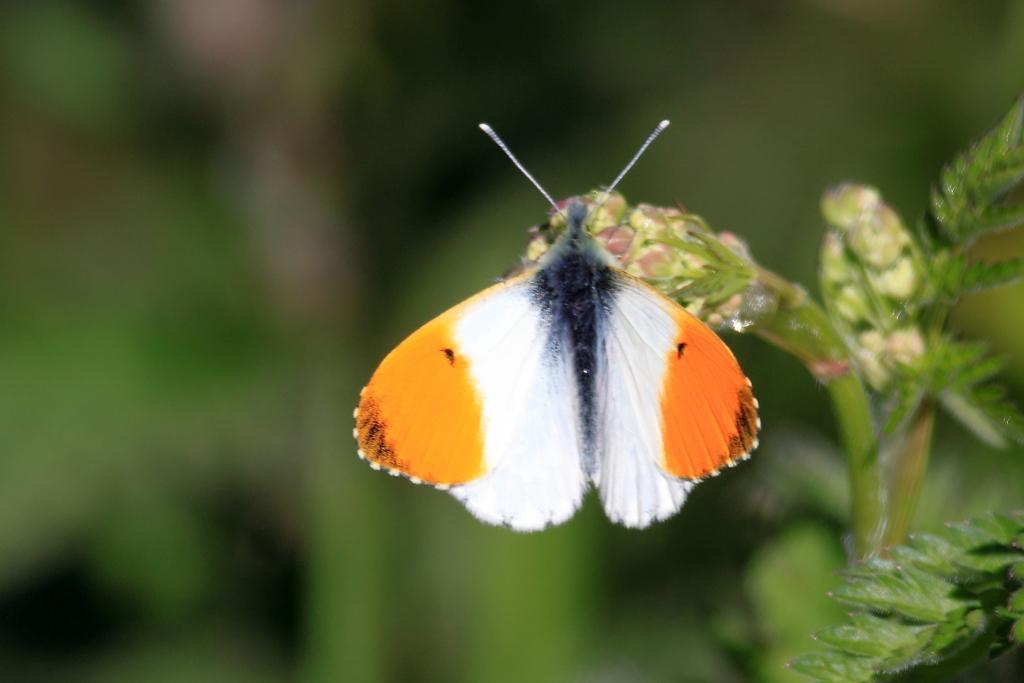How would you summarize this image in a sentence or two? Butterfly is highlighted in this picture. It is standing on a plant. This butterfly is in black, white and orange color. 